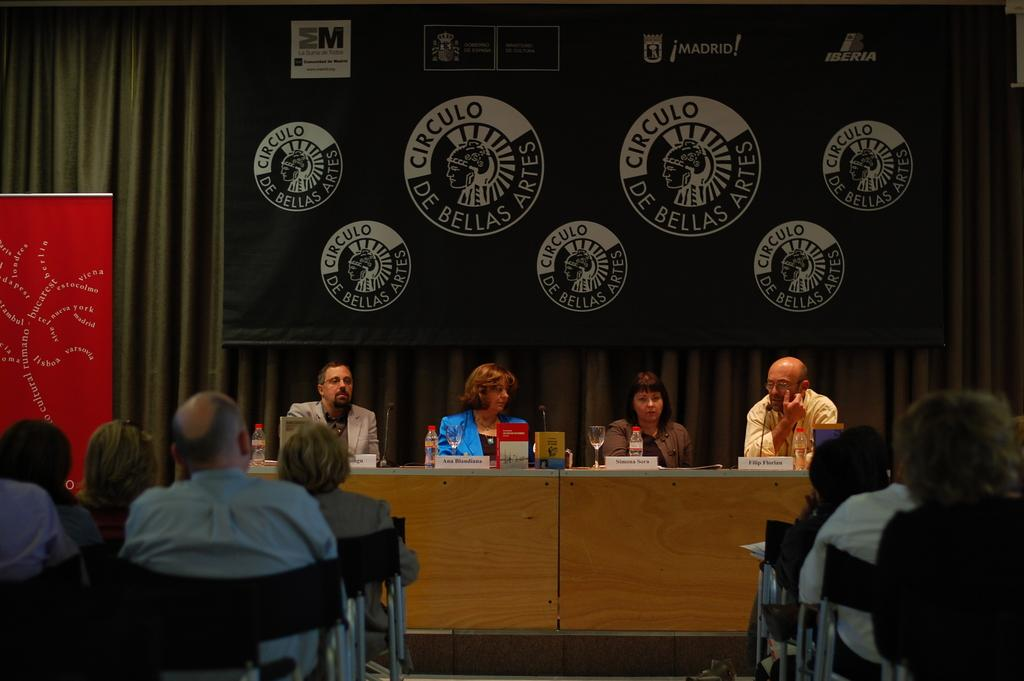How many people are present in the image? There are people in the image, but the exact number cannot be determined from the provided facts. What objects can be seen in the image besides people? There are bottles, a wooden table, a microphone (mike), glasses, chairs, curtains, and boards with text in the image. What type of surface is the microphone placed on? The microphone is placed on a wooden table in the image. What might the boards with text be used for? The boards with text might be used for displaying information or announcements. Where is the oven located in the image? There is no oven present in the image. What type of scale is being used by the people in the image? There is no scale present in the image. 